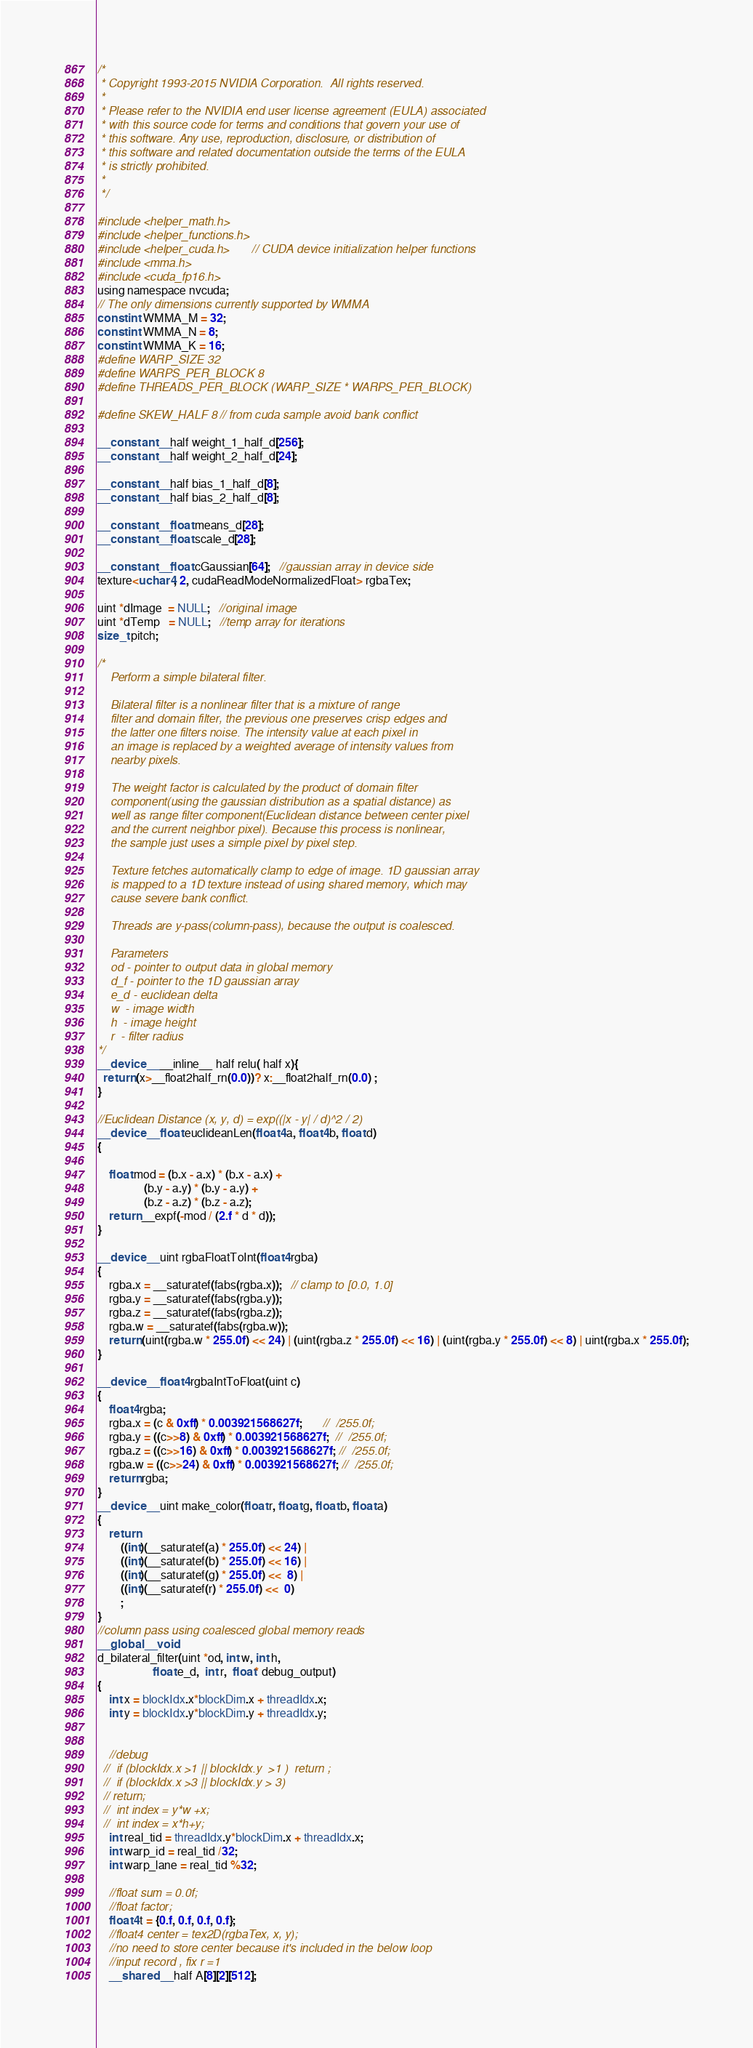<code> <loc_0><loc_0><loc_500><loc_500><_Cuda_>/*
 * Copyright 1993-2015 NVIDIA Corporation.  All rights reserved.
 *
 * Please refer to the NVIDIA end user license agreement (EULA) associated
 * with this source code for terms and conditions that govern your use of
 * this software. Any use, reproduction, disclosure, or distribution of
 * this software and related documentation outside the terms of the EULA
 * is strictly prohibited.
 *
 */

#include <helper_math.h>
#include <helper_functions.h>
#include <helper_cuda.h>       // CUDA device initialization helper functions
#include <mma.h>
#include <cuda_fp16.h>
using namespace nvcuda;
// The only dimensions currently supported by WMMA
const int WMMA_M = 32;
const int WMMA_N = 8;
const int WMMA_K = 16;
#define WARP_SIZE 32
#define WARPS_PER_BLOCK 8
#define THREADS_PER_BLOCK (WARP_SIZE * WARPS_PER_BLOCK)

#define SKEW_HALF 8 // from cuda sample avoid bank conflict

__constant__ half weight_1_half_d[256];
__constant__ half weight_2_half_d[24];

__constant__ half bias_1_half_d[8];
__constant__ half bias_2_half_d[8];

__constant__ float means_d[28];
__constant__ float scale_d[28];

__constant__ float cGaussian[64];   //gaussian array in device side
texture<uchar4, 2, cudaReadModeNormalizedFloat> rgbaTex;

uint *dImage  = NULL;   //original image
uint *dTemp   = NULL;   //temp array for iterations
size_t pitch;

/*
    Perform a simple bilateral filter.

    Bilateral filter is a nonlinear filter that is a mixture of range
    filter and domain filter, the previous one preserves crisp edges and
    the latter one filters noise. The intensity value at each pixel in
    an image is replaced by a weighted average of intensity values from
    nearby pixels.

    The weight factor is calculated by the product of domain filter
    component(using the gaussian distribution as a spatial distance) as
    well as range filter component(Euclidean distance between center pixel
    and the current neighbor pixel). Because this process is nonlinear,
    the sample just uses a simple pixel by pixel step.

    Texture fetches automatically clamp to edge of image. 1D gaussian array
    is mapped to a 1D texture instead of using shared memory, which may
    cause severe bank conflict.

    Threads are y-pass(column-pass), because the output is coalesced.

    Parameters
    od - pointer to output data in global memory
    d_f - pointer to the 1D gaussian array
    e_d - euclidean delta
    w  - image width
    h  - image height
    r  - filter radius
*/
__device__ __inline__ half relu( half x){
  return (x>__float2half_rn(0.0))? x:__float2half_rn(0.0) ;
}

//Euclidean Distance (x, y, d) = exp((|x - y| / d)^2 / 2)
__device__ float euclideanLen(float4 a, float4 b, float d)
{

    float mod = (b.x - a.x) * (b.x - a.x) +
                (b.y - a.y) * (b.y - a.y) +
                (b.z - a.z) * (b.z - a.z);
    return __expf(-mod / (2.f * d * d));
}

__device__ uint rgbaFloatToInt(float4 rgba)
{
    rgba.x = __saturatef(fabs(rgba.x));   // clamp to [0.0, 1.0]
    rgba.y = __saturatef(fabs(rgba.y));
    rgba.z = __saturatef(fabs(rgba.z));
    rgba.w = __saturatef(fabs(rgba.w));
    return (uint(rgba.w * 255.0f) << 24) | (uint(rgba.z * 255.0f) << 16) | (uint(rgba.y * 255.0f) << 8) | uint(rgba.x * 255.0f);
}

__device__ float4 rgbaIntToFloat(uint c)
{
    float4 rgba;
    rgba.x = (c & 0xff) * 0.003921568627f;       //  /255.0f;
    rgba.y = ((c>>8) & 0xff) * 0.003921568627f;  //  /255.0f;
    rgba.z = ((c>>16) & 0xff) * 0.003921568627f; //  /255.0f;
    rgba.w = ((c>>24) & 0xff) * 0.003921568627f; //  /255.0f;
    return rgba;
}
__device__ uint make_color(float r, float g, float b, float a)
{
    return
        ((int)(__saturatef(a) * 255.0f) << 24) |
        ((int)(__saturatef(b) * 255.0f) << 16) |
        ((int)(__saturatef(g) * 255.0f) <<  8) |
        ((int)(__saturatef(r) * 255.0f) <<  0)
        ;
}
//column pass using coalesced global memory reads
__global__ void
d_bilateral_filter(uint *od, int w, int h,
                   float e_d,  int r,  float* debug_output)
{
    int x = blockIdx.x*blockDim.x + threadIdx.x;
    int y = blockIdx.y*blockDim.y + threadIdx.y;


    //debug
  //  if (blockIdx.x >1 || blockIdx.y  >1 )  return ;
  //  if (blockIdx.x >3 || blockIdx.y > 3)
  // return;
  //  int index = y*w +x;
  //  int index = x*h+y;
    int real_tid = threadIdx.y*blockDim.x + threadIdx.x;
    int warp_id = real_tid /32;
    int warp_lane = real_tid %32;

    //float sum = 0.0f;
    //float factor;
    float4 t = {0.f, 0.f, 0.f, 0.f};
    //float4 center = tex2D(rgbaTex, x, y);
    //no need to store center because it's included in the below loop
    //input record , fix r =1
    __shared__ half A[8][2][512];</code> 